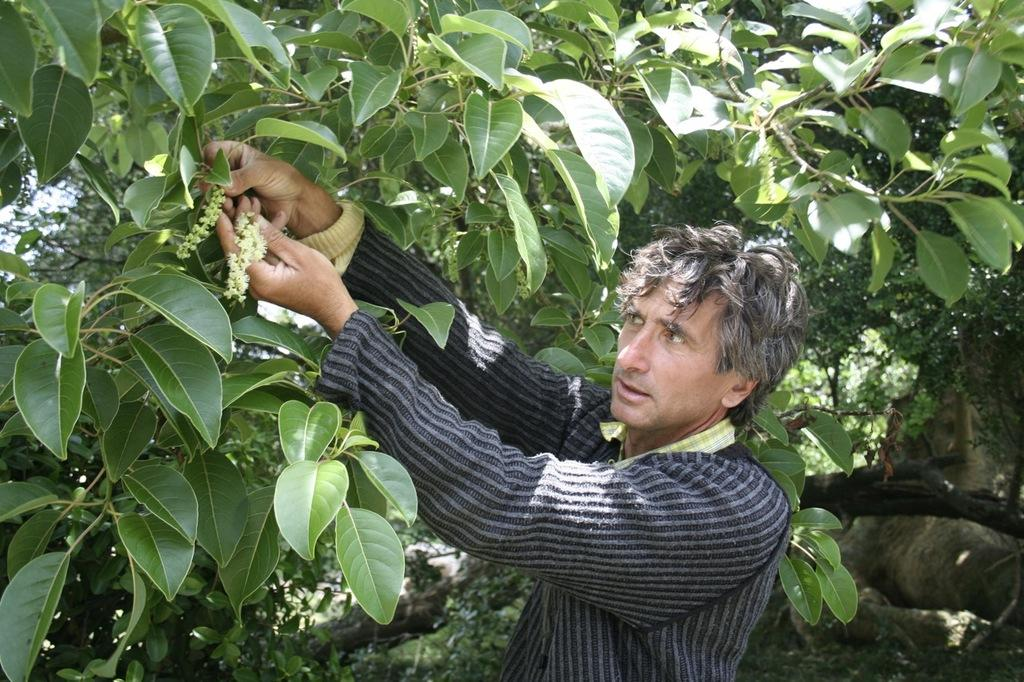What is the main subject in the foreground of the image? There is a person in the foreground of the image. What is the person doing in the image? The person is plucking flowers. What can be seen in the background of the image? There is a tree with leaves in the background of the image. What object is located on the right side of the image? There is a stone on the right side of the image. How many fingers does the person have on their left hand in the image? There is no information provided about the person's fingers in the image, so we cannot determine the number of fingers on their left hand. What type of wax is being used by the person to learn a new skill in the image? There is no wax or learning activity present in the image; the person is plucking flowers. 